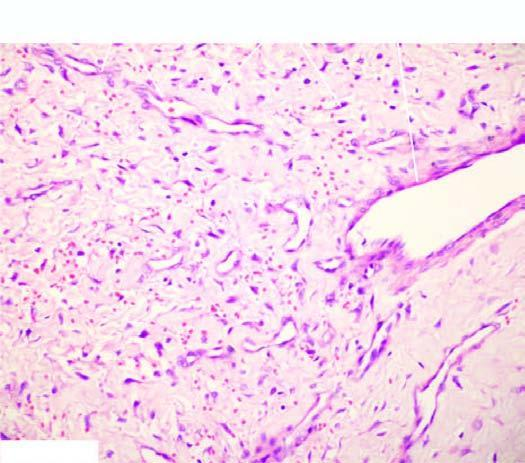what does the stroma have?
Answer the question using a single word or phrase. Stellate fibroblasts and mast cells 